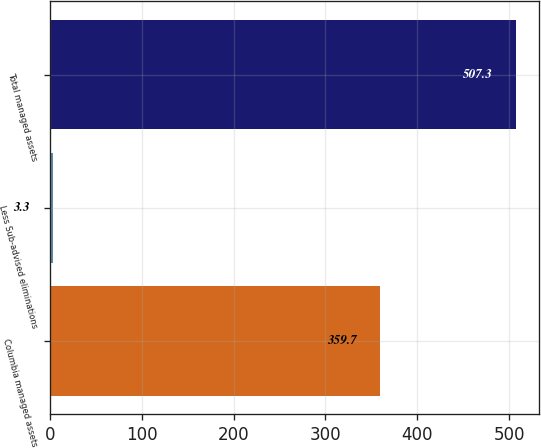Convert chart to OTSL. <chart><loc_0><loc_0><loc_500><loc_500><bar_chart><fcel>Columbia managed assets<fcel>Less Sub-advised eliminations<fcel>Total managed assets<nl><fcel>359.7<fcel>3.3<fcel>507.3<nl></chart> 